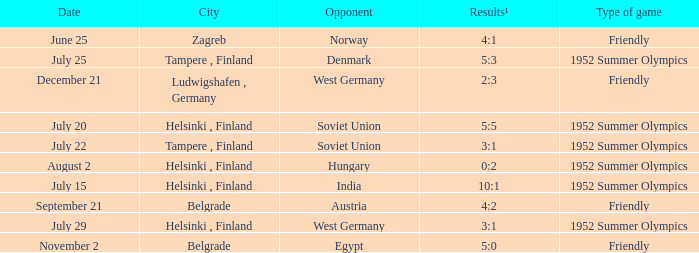What is the name of the City with December 21 as a Date? Ludwigshafen , Germany. 